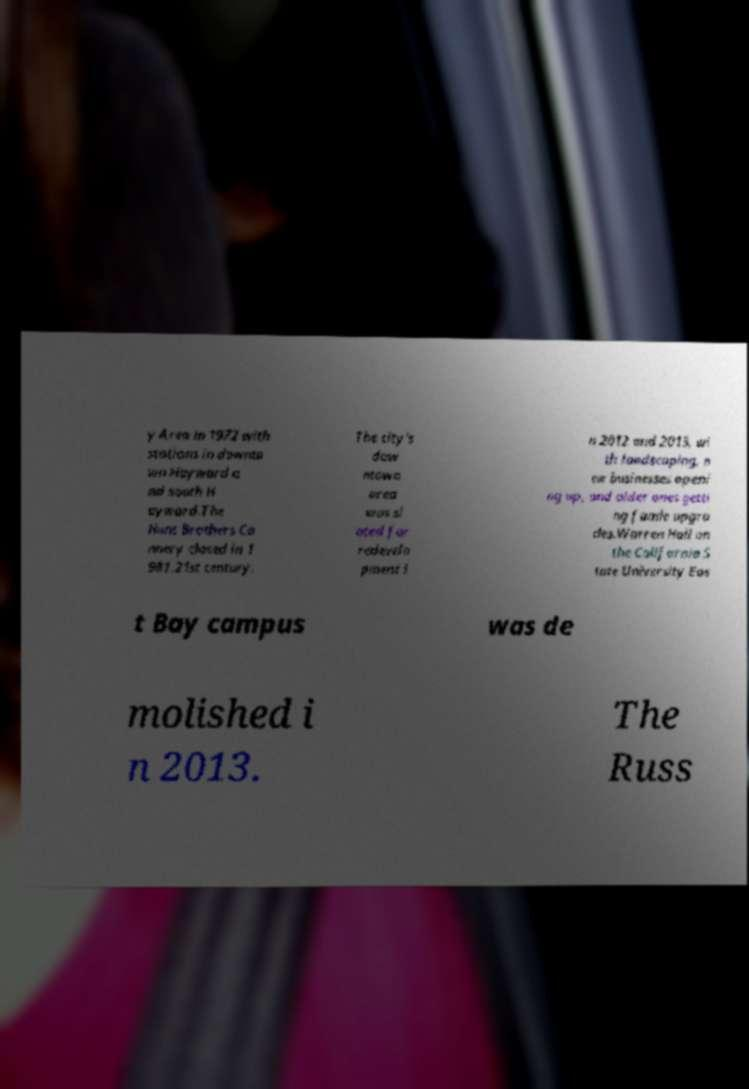For documentation purposes, I need the text within this image transcribed. Could you provide that? y Area in 1972 with stations in downto wn Hayward a nd south H ayward.The Hunt Brothers Ca nnery closed in 1 981.21st century. The city's dow ntown area was sl ated for redevelo pment i n 2012 and 2013, wi th landscaping, n ew businesses openi ng up, and older ones getti ng faade upgra des.Warren Hall on the California S tate University Eas t Bay campus was de molished i n 2013. The Russ 